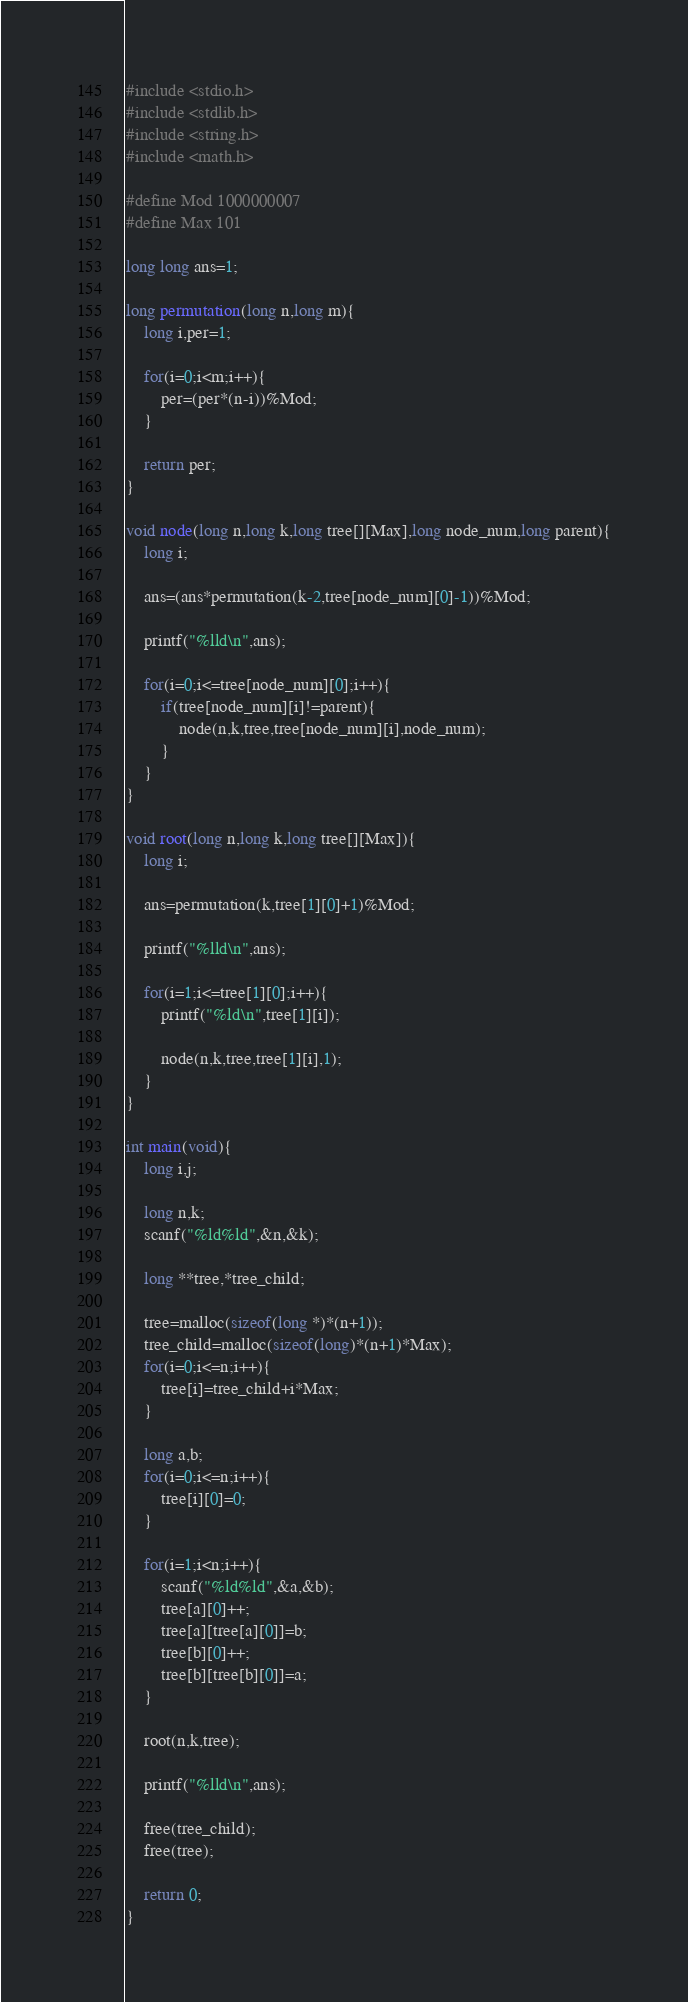Convert code to text. <code><loc_0><loc_0><loc_500><loc_500><_C_>#include <stdio.h>
#include <stdlib.h>
#include <string.h>
#include <math.h>

#define Mod 1000000007
#define Max 101

long long ans=1;

long permutation(long n,long m){
	long i,per=1;

	for(i=0;i<m;i++){
		per=(per*(n-i))%Mod;
	}

	return per;
}

void node(long n,long k,long tree[][Max],long node_num,long parent){
	long i;

	ans=(ans*permutation(k-2,tree[node_num][0]-1))%Mod;

	printf("%lld\n",ans);

	for(i=0;i<=tree[node_num][0];i++){
		if(tree[node_num][i]!=parent){
			node(n,k,tree,tree[node_num][i],node_num);
		}
	}
}

void root(long n,long k,long tree[][Max]){
	long i;

	ans=permutation(k,tree[1][0]+1)%Mod;

	printf("%lld\n",ans);

	for(i=1;i<=tree[1][0];i++){
		printf("%ld\n",tree[1][i]);

		node(n,k,tree,tree[1][i],1);
	}
}

int main(void){
	long i,j;

	long n,k;
	scanf("%ld%ld",&n,&k);

	long **tree,*tree_child;

	tree=malloc(sizeof(long *)*(n+1));
	tree_child=malloc(sizeof(long)*(n+1)*Max);
	for(i=0;i<=n;i++){
		tree[i]=tree_child+i*Max;
	}

	long a,b;
	for(i=0;i<=n;i++){
		tree[i][0]=0;
	}

	for(i=1;i<n;i++){
		scanf("%ld%ld",&a,&b);
		tree[a][0]++;
		tree[a][tree[a][0]]=b;
		tree[b][0]++;
		tree[b][tree[b][0]]=a;
	}

	root(n,k,tree);

	printf("%lld\n",ans);

	free(tree_child);
	free(tree);

	return 0;
}
</code> 